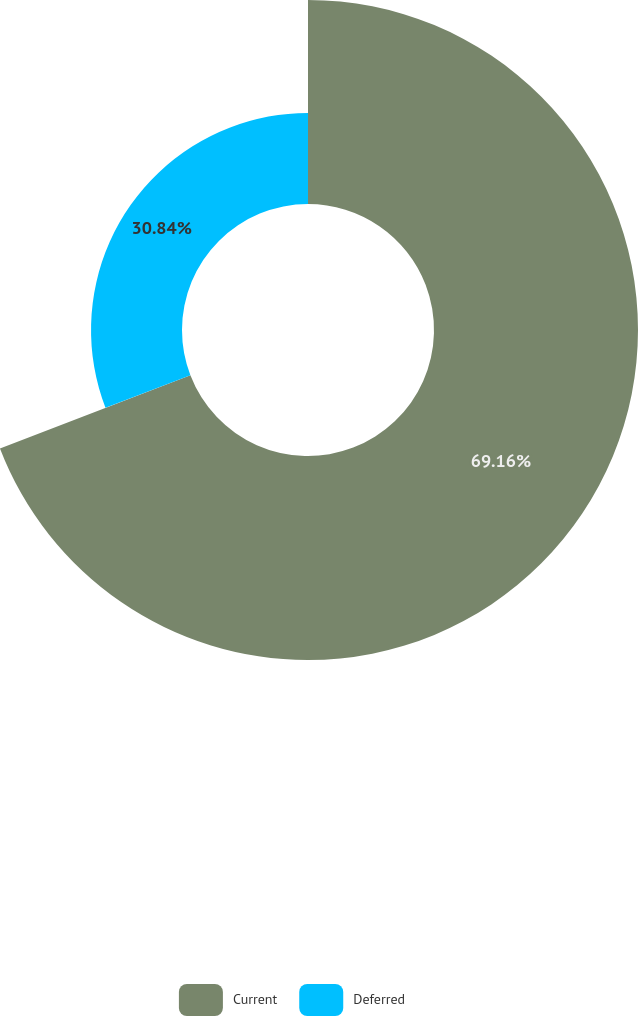<chart> <loc_0><loc_0><loc_500><loc_500><pie_chart><fcel>Current<fcel>Deferred<nl><fcel>69.16%<fcel>30.84%<nl></chart> 